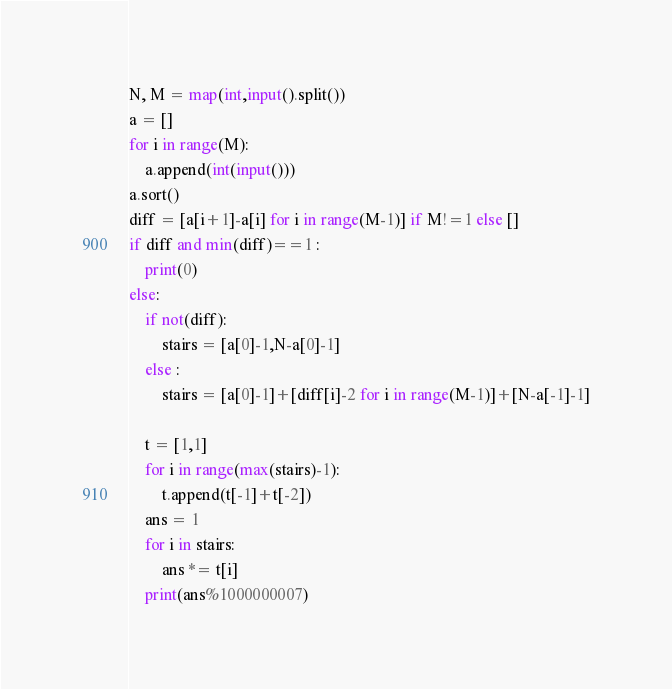<code> <loc_0><loc_0><loc_500><loc_500><_Python_>N, M = map(int,input().split())
a = [] 
for i in range(M):
    a.append(int(input()))
a.sort()
diff = [a[i+1]-a[i] for i in range(M-1)] if M!=1 else []
if diff and min(diff)==1 :
    print(0)
else:
    if not(diff):
        stairs = [a[0]-1,N-a[0]-1]
    else :
        stairs = [a[0]-1]+[diff[i]-2 for i in range(M-1)]+[N-a[-1]-1]
    
    t = [1,1]
    for i in range(max(stairs)-1):
        t.append(t[-1]+t[-2])
    ans = 1
    for i in stairs:
        ans *= t[i]
    print(ans%1000000007)</code> 